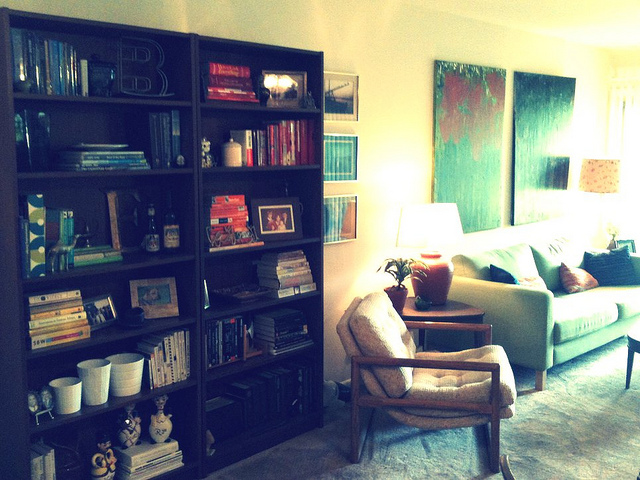Please identify all text content in this image. B 